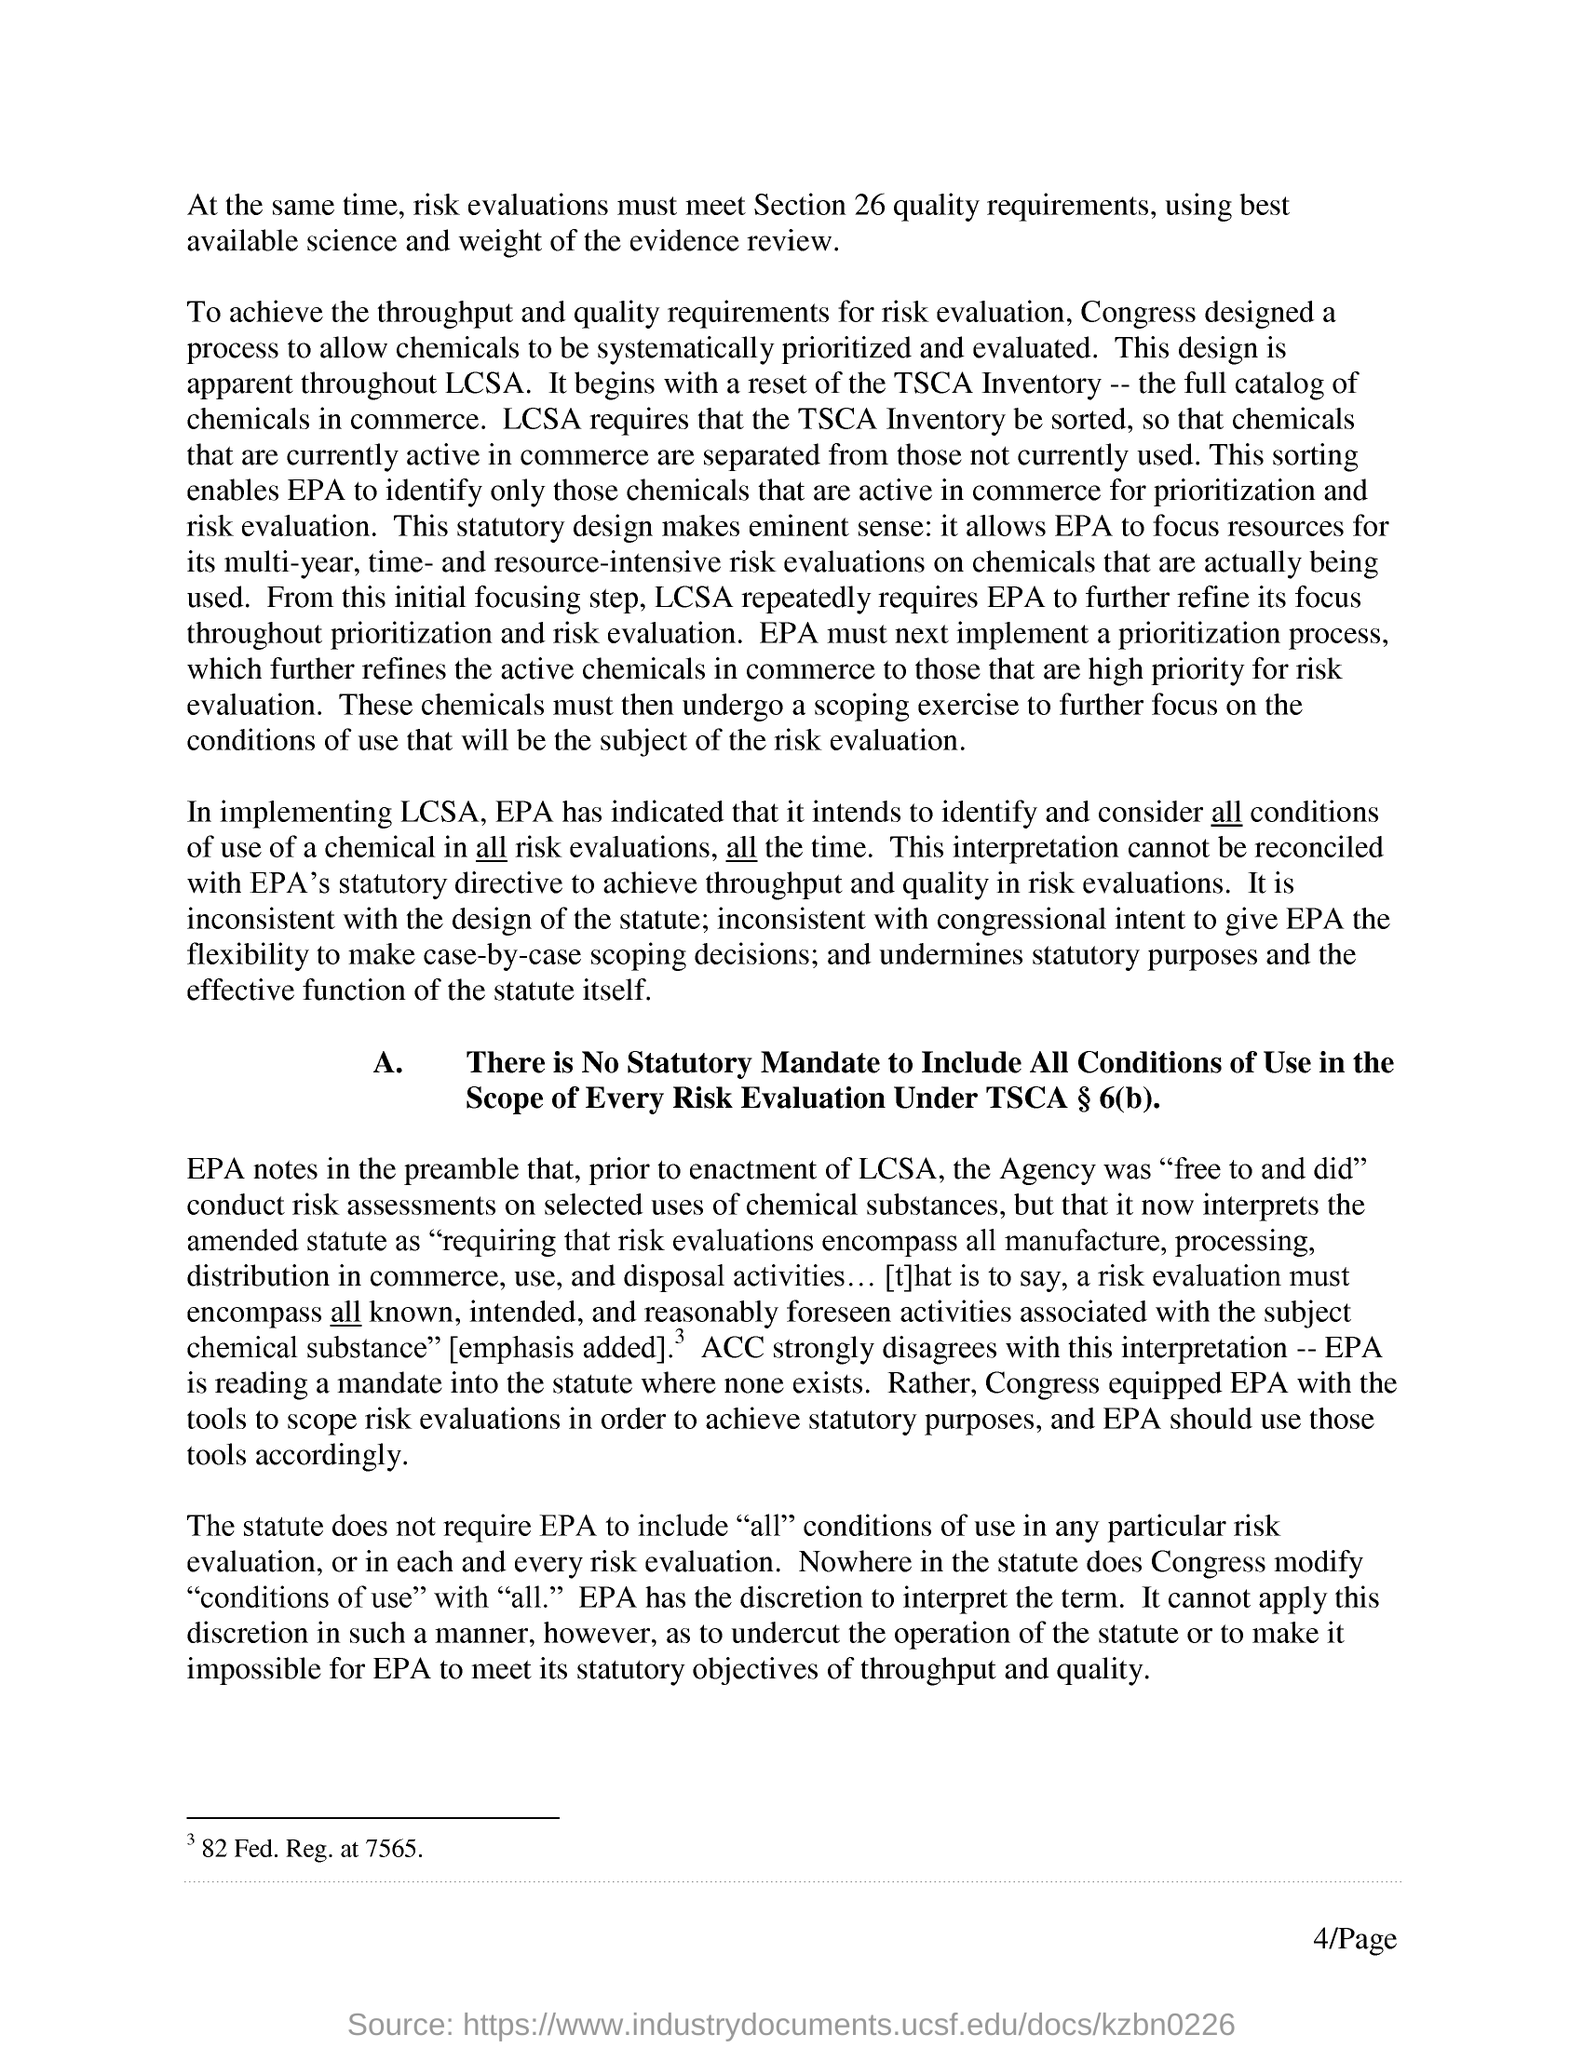Point out several critical features in this image. The page number is 4, as declared. 